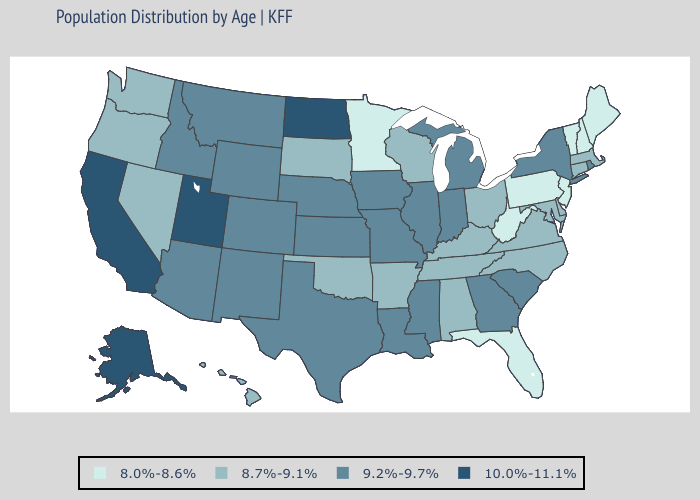Does Mississippi have the same value as Missouri?
Be succinct. Yes. Does Oregon have the lowest value in the West?
Quick response, please. Yes. What is the value of Kentucky?
Write a very short answer. 8.7%-9.1%. Name the states that have a value in the range 10.0%-11.1%?
Quick response, please. Alaska, California, North Dakota, Utah. Among the states that border Kansas , does Oklahoma have the highest value?
Keep it brief. No. Does Texas have the lowest value in the USA?
Answer briefly. No. Which states have the lowest value in the Northeast?
Quick response, please. Maine, New Hampshire, New Jersey, Pennsylvania, Vermont. Name the states that have a value in the range 8.0%-8.6%?
Quick response, please. Florida, Maine, Minnesota, New Hampshire, New Jersey, Pennsylvania, Vermont, West Virginia. What is the lowest value in states that border Maine?
Write a very short answer. 8.0%-8.6%. What is the lowest value in states that border Pennsylvania?
Quick response, please. 8.0%-8.6%. What is the value of Hawaii?
Keep it brief. 8.7%-9.1%. What is the value of Oregon?
Answer briefly. 8.7%-9.1%. Name the states that have a value in the range 8.7%-9.1%?
Concise answer only. Alabama, Arkansas, Connecticut, Delaware, Hawaii, Kentucky, Maryland, Massachusetts, Nevada, North Carolina, Ohio, Oklahoma, Oregon, South Dakota, Tennessee, Virginia, Washington, Wisconsin. 